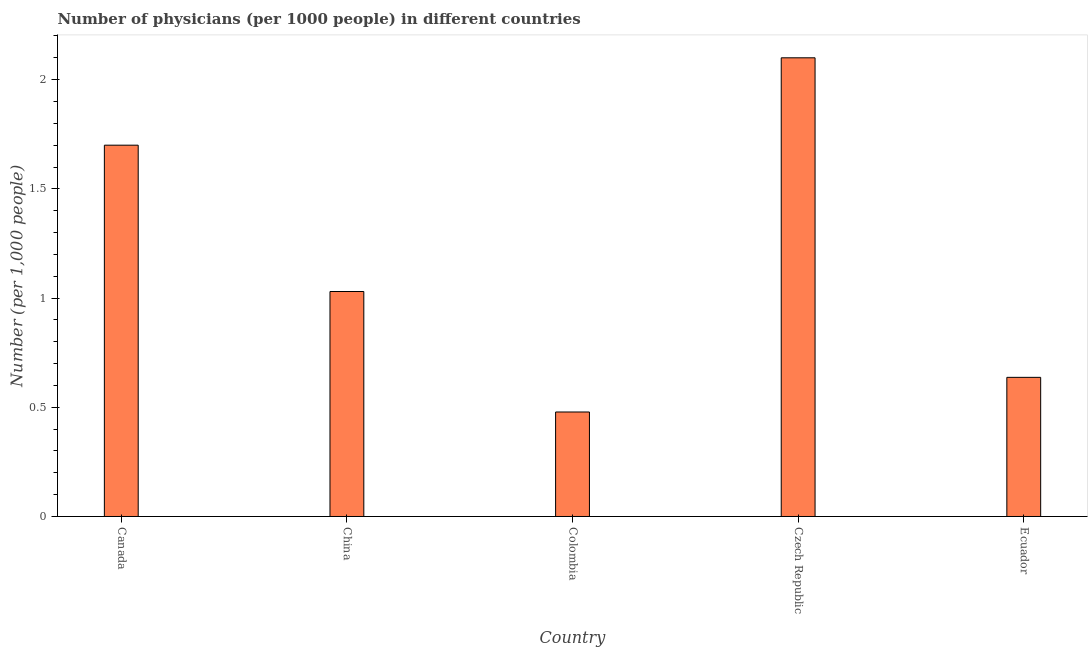Does the graph contain any zero values?
Ensure brevity in your answer.  No. What is the title of the graph?
Provide a succinct answer. Number of physicians (per 1000 people) in different countries. What is the label or title of the X-axis?
Your answer should be very brief. Country. What is the label or title of the Y-axis?
Provide a short and direct response. Number (per 1,0 people). Across all countries, what is the minimum number of physicians?
Give a very brief answer. 0.48. In which country was the number of physicians maximum?
Your answer should be very brief. Czech Republic. What is the sum of the number of physicians?
Make the answer very short. 5.95. What is the difference between the number of physicians in Canada and Czech Republic?
Your answer should be very brief. -0.4. What is the average number of physicians per country?
Provide a short and direct response. 1.19. What is the median number of physicians?
Your answer should be very brief. 1.03. What is the ratio of the number of physicians in Canada to that in Czech Republic?
Your response must be concise. 0.81. Is the difference between the number of physicians in Colombia and Ecuador greater than the difference between any two countries?
Your response must be concise. No. What is the difference between the highest and the second highest number of physicians?
Your answer should be compact. 0.4. Is the sum of the number of physicians in China and Czech Republic greater than the maximum number of physicians across all countries?
Give a very brief answer. Yes. What is the difference between the highest and the lowest number of physicians?
Offer a very short reply. 1.62. Are all the bars in the graph horizontal?
Provide a short and direct response. No. How many countries are there in the graph?
Give a very brief answer. 5. What is the difference between two consecutive major ticks on the Y-axis?
Offer a very short reply. 0.5. What is the Number (per 1,000 people) in Canada?
Your answer should be compact. 1.7. What is the Number (per 1,000 people) in China?
Your answer should be compact. 1.03. What is the Number (per 1,000 people) in Colombia?
Offer a very short reply. 0.48. What is the Number (per 1,000 people) of Czech Republic?
Your answer should be compact. 2.1. What is the Number (per 1,000 people) in Ecuador?
Provide a succinct answer. 0.64. What is the difference between the Number (per 1,000 people) in Canada and China?
Your response must be concise. 0.67. What is the difference between the Number (per 1,000 people) in Canada and Colombia?
Your answer should be compact. 1.22. What is the difference between the Number (per 1,000 people) in Canada and Czech Republic?
Give a very brief answer. -0.4. What is the difference between the Number (per 1,000 people) in Canada and Ecuador?
Give a very brief answer. 1.06. What is the difference between the Number (per 1,000 people) in China and Colombia?
Your answer should be very brief. 0.55. What is the difference between the Number (per 1,000 people) in China and Czech Republic?
Give a very brief answer. -1.07. What is the difference between the Number (per 1,000 people) in China and Ecuador?
Offer a terse response. 0.39. What is the difference between the Number (per 1,000 people) in Colombia and Czech Republic?
Ensure brevity in your answer.  -1.62. What is the difference between the Number (per 1,000 people) in Colombia and Ecuador?
Your response must be concise. -0.16. What is the difference between the Number (per 1,000 people) in Czech Republic and Ecuador?
Offer a very short reply. 1.46. What is the ratio of the Number (per 1,000 people) in Canada to that in China?
Make the answer very short. 1.65. What is the ratio of the Number (per 1,000 people) in Canada to that in Colombia?
Your response must be concise. 3.55. What is the ratio of the Number (per 1,000 people) in Canada to that in Czech Republic?
Your response must be concise. 0.81. What is the ratio of the Number (per 1,000 people) in Canada to that in Ecuador?
Make the answer very short. 2.67. What is the ratio of the Number (per 1,000 people) in China to that in Colombia?
Offer a very short reply. 2.15. What is the ratio of the Number (per 1,000 people) in China to that in Czech Republic?
Your answer should be very brief. 0.49. What is the ratio of the Number (per 1,000 people) in China to that in Ecuador?
Provide a succinct answer. 1.62. What is the ratio of the Number (per 1,000 people) in Colombia to that in Czech Republic?
Make the answer very short. 0.23. What is the ratio of the Number (per 1,000 people) in Colombia to that in Ecuador?
Provide a succinct answer. 0.75. What is the ratio of the Number (per 1,000 people) in Czech Republic to that in Ecuador?
Your answer should be very brief. 3.3. 